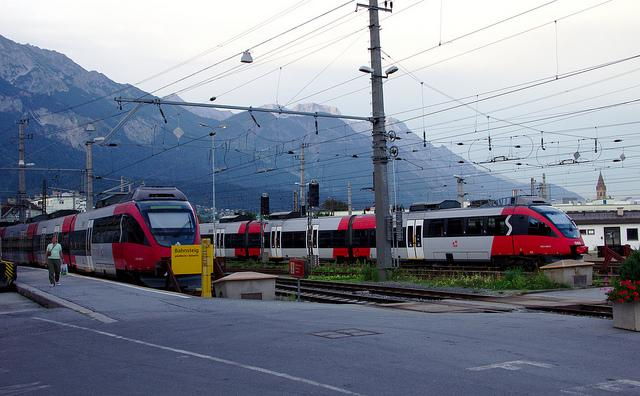What helps for transponders to communicate with the cab and train control systems? Please explain your reasoning. signal. The signal helps. 